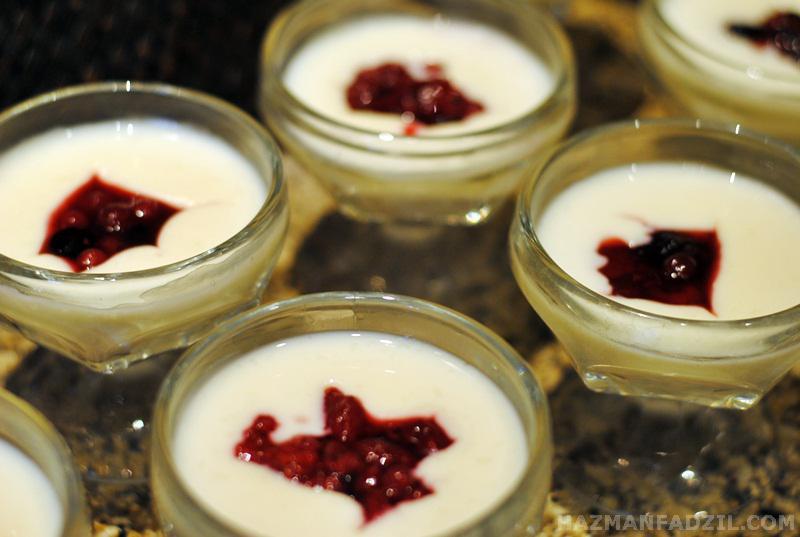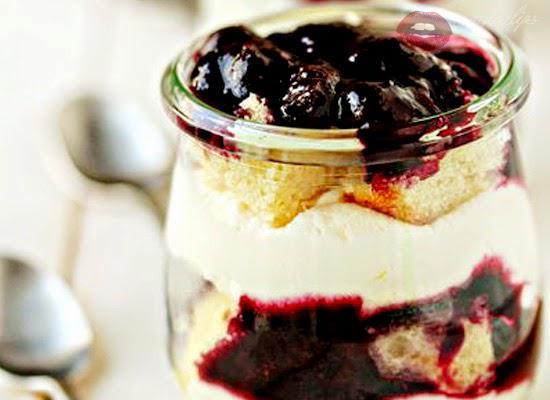The first image is the image on the left, the second image is the image on the right. Evaluate the accuracy of this statement regarding the images: "There are four glasses of a whipped cream topped dessert in one of the images.". Is it true? Answer yes or no. Yes. The first image is the image on the left, the second image is the image on the right. Given the left and right images, does the statement "All of the desserts shown have some type of fruit on top." hold true? Answer yes or no. Yes. 